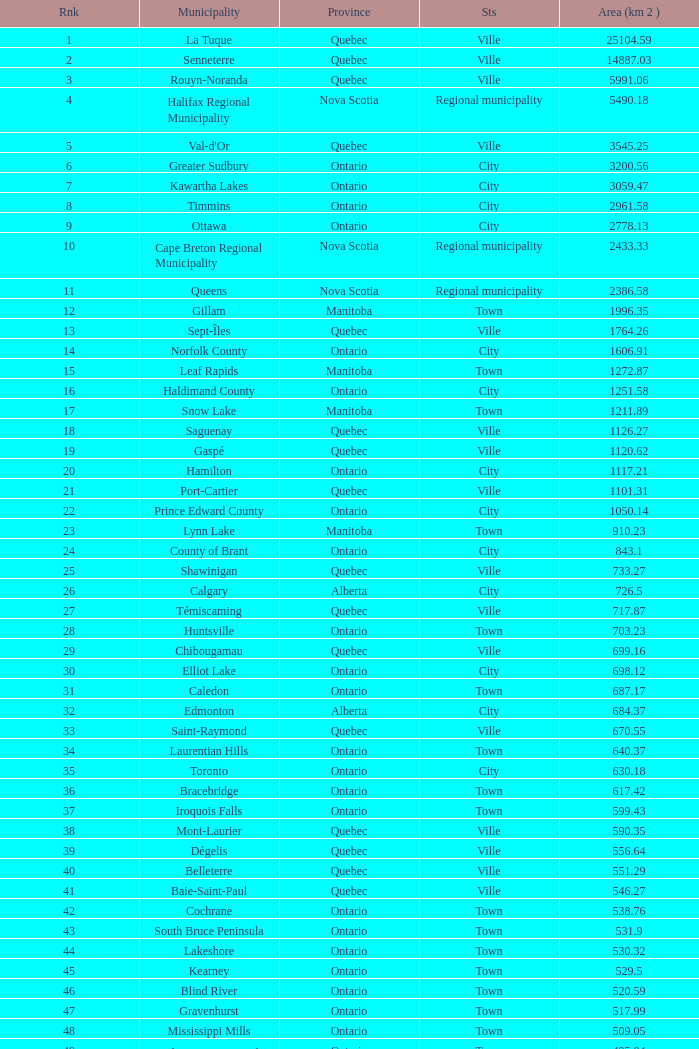Could you help me parse every detail presented in this table? {'header': ['Rnk', 'Municipality', 'Province', 'Sts', 'Area (km 2 )'], 'rows': [['1', 'La Tuque', 'Quebec', 'Ville', '25104.59'], ['2', 'Senneterre', 'Quebec', 'Ville', '14887.03'], ['3', 'Rouyn-Noranda', 'Quebec', 'Ville', '5991.06'], ['4', 'Halifax Regional Municipality', 'Nova Scotia', 'Regional municipality', '5490.18'], ['5', "Val-d'Or", 'Quebec', 'Ville', '3545.25'], ['6', 'Greater Sudbury', 'Ontario', 'City', '3200.56'], ['7', 'Kawartha Lakes', 'Ontario', 'City', '3059.47'], ['8', 'Timmins', 'Ontario', 'City', '2961.58'], ['9', 'Ottawa', 'Ontario', 'City', '2778.13'], ['10', 'Cape Breton Regional Municipality', 'Nova Scotia', 'Regional municipality', '2433.33'], ['11', 'Queens', 'Nova Scotia', 'Regional municipality', '2386.58'], ['12', 'Gillam', 'Manitoba', 'Town', '1996.35'], ['13', 'Sept-Îles', 'Quebec', 'Ville', '1764.26'], ['14', 'Norfolk County', 'Ontario', 'City', '1606.91'], ['15', 'Leaf Rapids', 'Manitoba', 'Town', '1272.87'], ['16', 'Haldimand County', 'Ontario', 'City', '1251.58'], ['17', 'Snow Lake', 'Manitoba', 'Town', '1211.89'], ['18', 'Saguenay', 'Quebec', 'Ville', '1126.27'], ['19', 'Gaspé', 'Quebec', 'Ville', '1120.62'], ['20', 'Hamilton', 'Ontario', 'City', '1117.21'], ['21', 'Port-Cartier', 'Quebec', 'Ville', '1101.31'], ['22', 'Prince Edward County', 'Ontario', 'City', '1050.14'], ['23', 'Lynn Lake', 'Manitoba', 'Town', '910.23'], ['24', 'County of Brant', 'Ontario', 'City', '843.1'], ['25', 'Shawinigan', 'Quebec', 'Ville', '733.27'], ['26', 'Calgary', 'Alberta', 'City', '726.5'], ['27', 'Témiscaming', 'Quebec', 'Ville', '717.87'], ['28', 'Huntsville', 'Ontario', 'Town', '703.23'], ['29', 'Chibougamau', 'Quebec', 'Ville', '699.16'], ['30', 'Elliot Lake', 'Ontario', 'City', '698.12'], ['31', 'Caledon', 'Ontario', 'Town', '687.17'], ['32', 'Edmonton', 'Alberta', 'City', '684.37'], ['33', 'Saint-Raymond', 'Quebec', 'Ville', '670.55'], ['34', 'Laurentian Hills', 'Ontario', 'Town', '640.37'], ['35', 'Toronto', 'Ontario', 'City', '630.18'], ['36', 'Bracebridge', 'Ontario', 'Town', '617.42'], ['37', 'Iroquois Falls', 'Ontario', 'Town', '599.43'], ['38', 'Mont-Laurier', 'Quebec', 'Ville', '590.35'], ['39', 'Dégelis', 'Quebec', 'Ville', '556.64'], ['40', 'Belleterre', 'Quebec', 'Ville', '551.29'], ['41', 'Baie-Saint-Paul', 'Quebec', 'Ville', '546.27'], ['42', 'Cochrane', 'Ontario', 'Town', '538.76'], ['43', 'South Bruce Peninsula', 'Ontario', 'Town', '531.9'], ['44', 'Lakeshore', 'Ontario', 'Town', '530.32'], ['45', 'Kearney', 'Ontario', 'Town', '529.5'], ['46', 'Blind River', 'Ontario', 'Town', '520.59'], ['47', 'Gravenhurst', 'Ontario', 'Town', '517.99'], ['48', 'Mississippi Mills', 'Ontario', 'Town', '509.05'], ['49', 'Northeastern Manitoulin and the Islands', 'Ontario', 'Town', '495.04'], ['50', 'Quinte West', 'Ontario', 'City', '493.85'], ['51', 'Mirabel', 'Quebec', 'Ville', '485.51'], ['52', 'Fermont', 'Quebec', 'Ville', '470.67'], ['53', 'Winnipeg', 'Manitoba', 'City', '464.01'], ['54', 'Greater Napanee', 'Ontario', 'Town', '459.71'], ['55', 'La Malbaie', 'Quebec', 'Ville', '459.34'], ['56', 'Rivière-Rouge', 'Quebec', 'Ville', '454.99'], ['57', 'Québec City', 'Quebec', 'Ville', '454.26'], ['58', 'Kingston', 'Ontario', 'City', '450.39'], ['59', 'Lévis', 'Quebec', 'Ville', '449.32'], ['60', "St. John's", 'Newfoundland and Labrador', 'City', '446.04'], ['61', 'Bécancour', 'Quebec', 'Ville', '441'], ['62', 'Percé', 'Quebec', 'Ville', '432.39'], ['63', 'Amos', 'Quebec', 'Ville', '430.06'], ['64', 'London', 'Ontario', 'City', '420.57'], ['65', 'Chandler', 'Quebec', 'Ville', '419.5'], ['66', 'Whitehorse', 'Yukon', 'City', '416.43'], ['67', 'Gracefield', 'Quebec', 'Ville', '386.21'], ['68', 'Baie Verte', 'Newfoundland and Labrador', 'Town', '371.07'], ['69', 'Milton', 'Ontario', 'Town', '366.61'], ['70', 'Montreal', 'Quebec', 'Ville', '365.13'], ['71', 'Saint-Félicien', 'Quebec', 'Ville', '363.57'], ['72', 'Abbotsford', 'British Columbia', 'City', '359.36'], ['73', 'Sherbrooke', 'Quebec', 'Ville', '353.46'], ['74', 'Gatineau', 'Quebec', 'Ville', '342.32'], ['75', 'Pohénégamook', 'Quebec', 'Ville', '340.33'], ['76', 'Baie-Comeau', 'Quebec', 'Ville', '338.88'], ['77', 'Thunder Bay', 'Ontario', 'City', '328.48'], ['78', 'Plympton–Wyoming', 'Ontario', 'Town', '318.76'], ['79', 'Surrey', 'British Columbia', 'City', '317.19'], ['80', 'Prince George', 'British Columbia', 'City', '316'], ['81', 'Saint John', 'New Brunswick', 'City', '315.49'], ['82', 'North Bay', 'Ontario', 'City', '314.91'], ['83', 'Happy Valley-Goose Bay', 'Newfoundland and Labrador', 'Town', '305.85'], ['84', 'Minto', 'Ontario', 'Town', '300.37'], ['85', 'Kamloops', 'British Columbia', 'City', '297.3'], ['86', 'Erin', 'Ontario', 'Town', '296.98'], ['87', 'Clarence-Rockland', 'Ontario', 'City', '296.53'], ['88', 'Cookshire-Eaton', 'Quebec', 'Ville', '295.93'], ['89', 'Dolbeau-Mistassini', 'Quebec', 'Ville', '295.67'], ['90', 'Trois-Rivières', 'Quebec', 'Ville', '288.92'], ['91', 'Mississauga', 'Ontario', 'City', '288.53'], ['92', 'Georgina', 'Ontario', 'Town', '287.72'], ['93', 'The Blue Mountains', 'Ontario', 'Town', '286.78'], ['94', 'Innisfil', 'Ontario', 'Town', '284.18'], ['95', 'Essex', 'Ontario', 'Town', '277.95'], ['96', 'Mono', 'Ontario', 'Town', '277.67'], ['97', 'Halton Hills', 'Ontario', 'Town', '276.26'], ['98', 'New Tecumseth', 'Ontario', 'Town', '274.18'], ['99', 'Vaughan', 'Ontario', 'City', '273.58'], ['100', 'Brampton', 'Ontario', 'City', '266.71']]} What is the highest Area (KM 2) for the Province of Ontario, that has the Status of Town, a Municipality of Minto, and a Rank that's smaller than 84? None. 